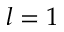<formula> <loc_0><loc_0><loc_500><loc_500>l = 1</formula> 